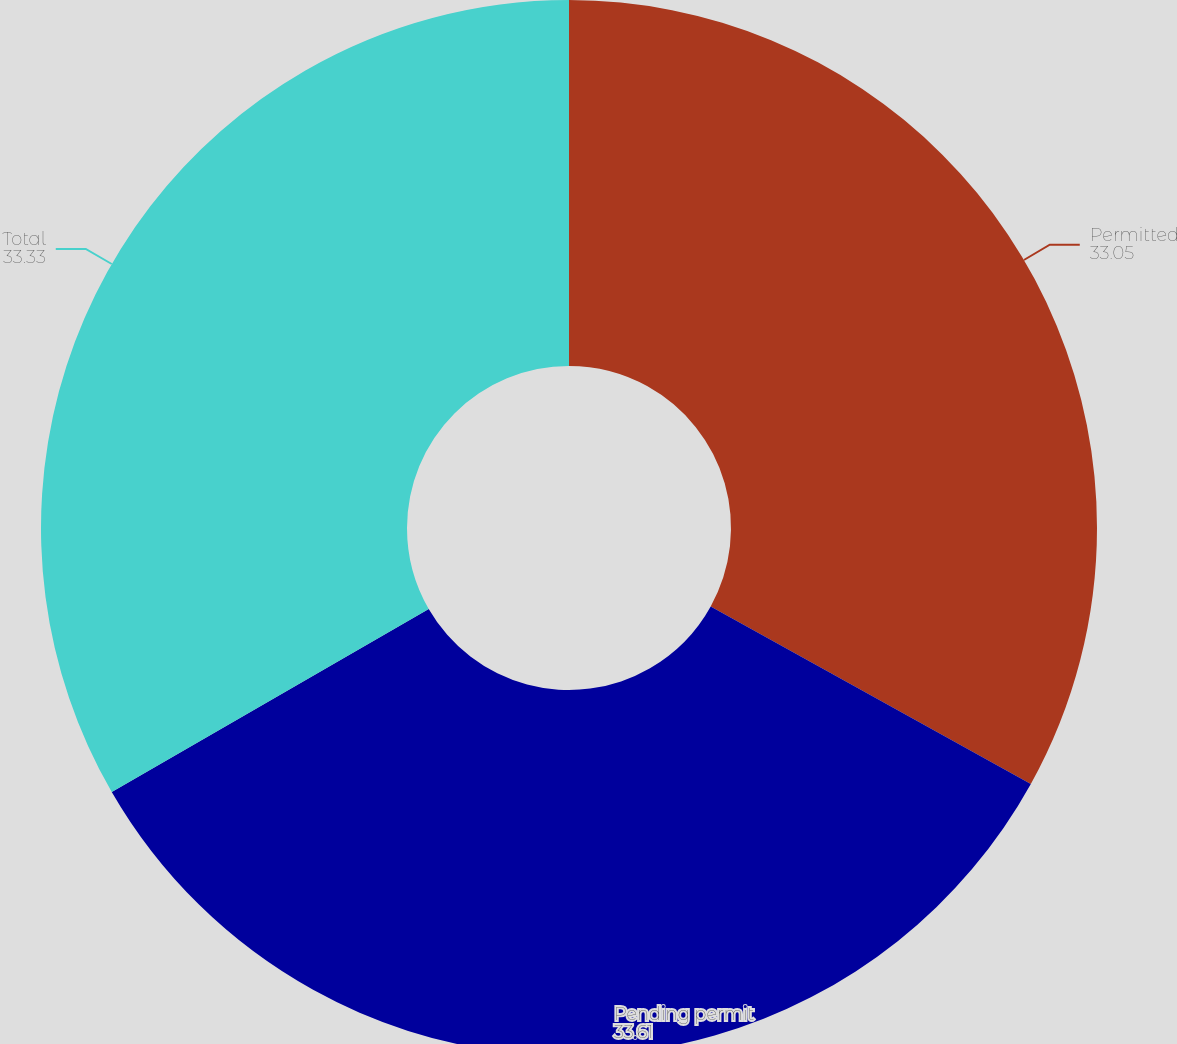Convert chart. <chart><loc_0><loc_0><loc_500><loc_500><pie_chart><fcel>Permitted<fcel>Pending permit<fcel>Total<nl><fcel>33.05%<fcel>33.61%<fcel>33.33%<nl></chart> 